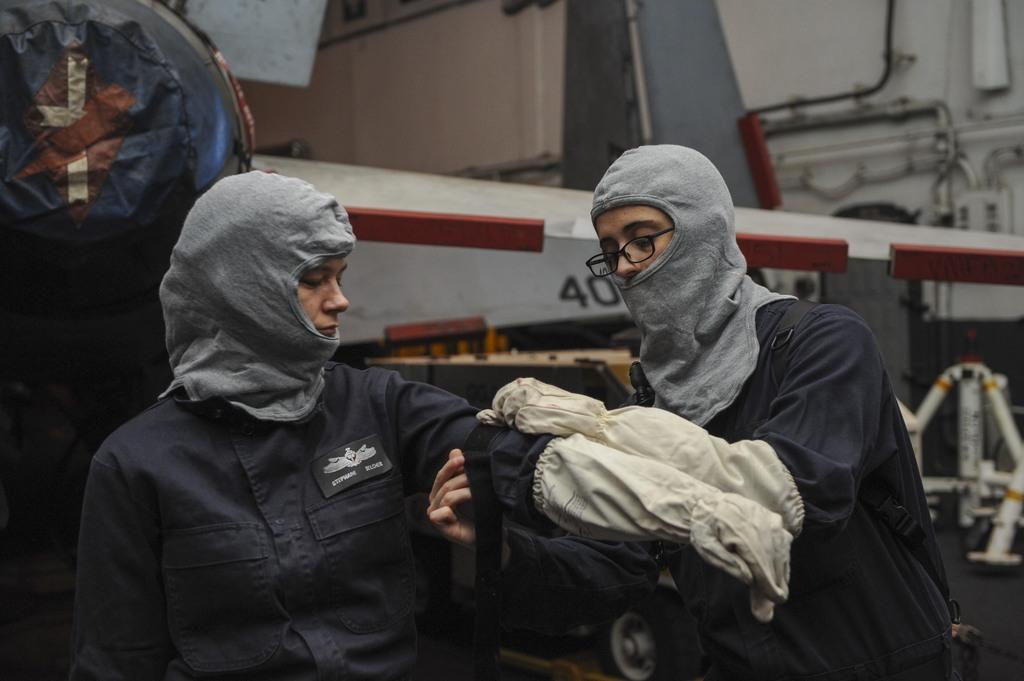How many people are in the image? There are two women in the image. Can you describe one of the women's appearance? One of the women is wearing spectacles. What type of nut is the woman holding in the image? There is no nut present in the image; both women are visible, but neither is holding a nut. 